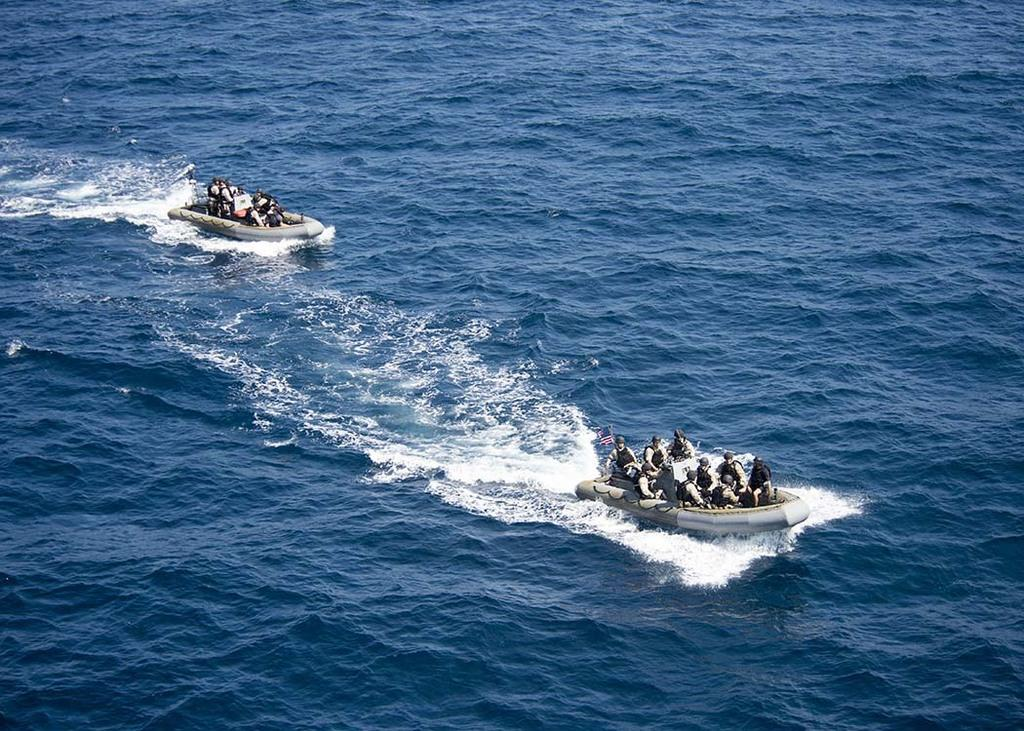How many persons are in the image? There are persons in the image. What are the persons doing in the image? The persons are sitting in two boats. Where are the boats located in the image? The boats are on the water. What type of haircut does the aunt have in the image? There is no aunt present in the image, and therefore no haircut can be observed. 